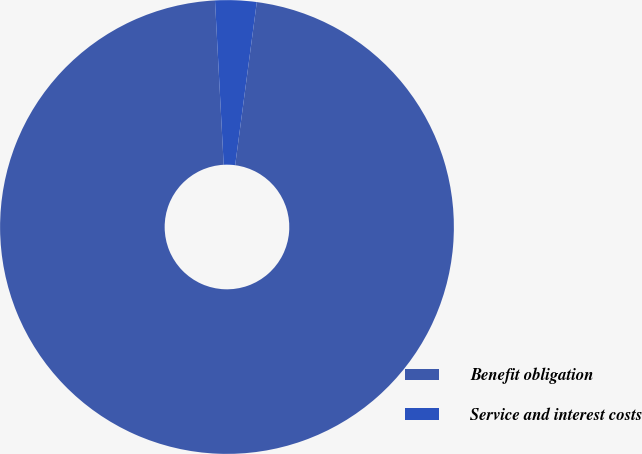Convert chart to OTSL. <chart><loc_0><loc_0><loc_500><loc_500><pie_chart><fcel>Benefit obligation<fcel>Service and interest costs<nl><fcel>97.06%<fcel>2.94%<nl></chart> 